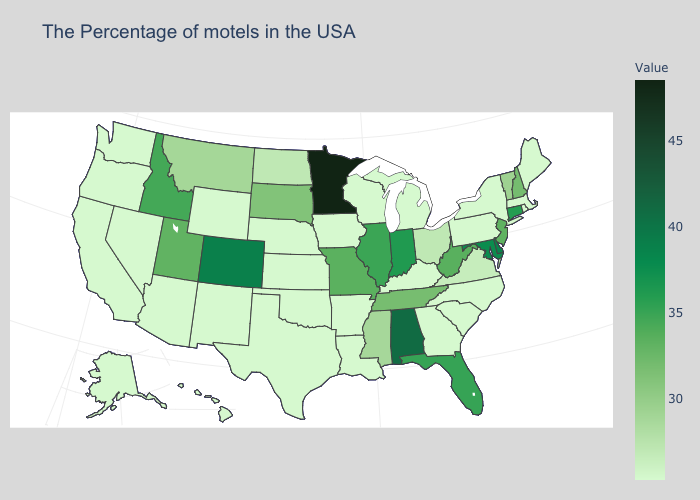Among the states that border California , which have the lowest value?
Write a very short answer. Arizona, Nevada, Oregon. Which states have the highest value in the USA?
Be succinct. Minnesota. Does Arizona have the highest value in the USA?
Answer briefly. No. Which states have the highest value in the USA?
Short answer required. Minnesota. Among the states that border Delaware , which have the highest value?
Write a very short answer. Maryland. Does Illinois have the lowest value in the MidWest?
Quick response, please. No. Which states have the lowest value in the USA?
Give a very brief answer. Maine, Massachusetts, Rhode Island, New York, Pennsylvania, North Carolina, South Carolina, Georgia, Michigan, Kentucky, Wisconsin, Louisiana, Arkansas, Iowa, Kansas, Nebraska, Oklahoma, Texas, Wyoming, New Mexico, Arizona, Nevada, California, Washington, Oregon, Alaska, Hawaii. Among the states that border New Mexico , does Utah have the highest value?
Concise answer only. No. Does New Jersey have the highest value in the USA?
Keep it brief. No. 